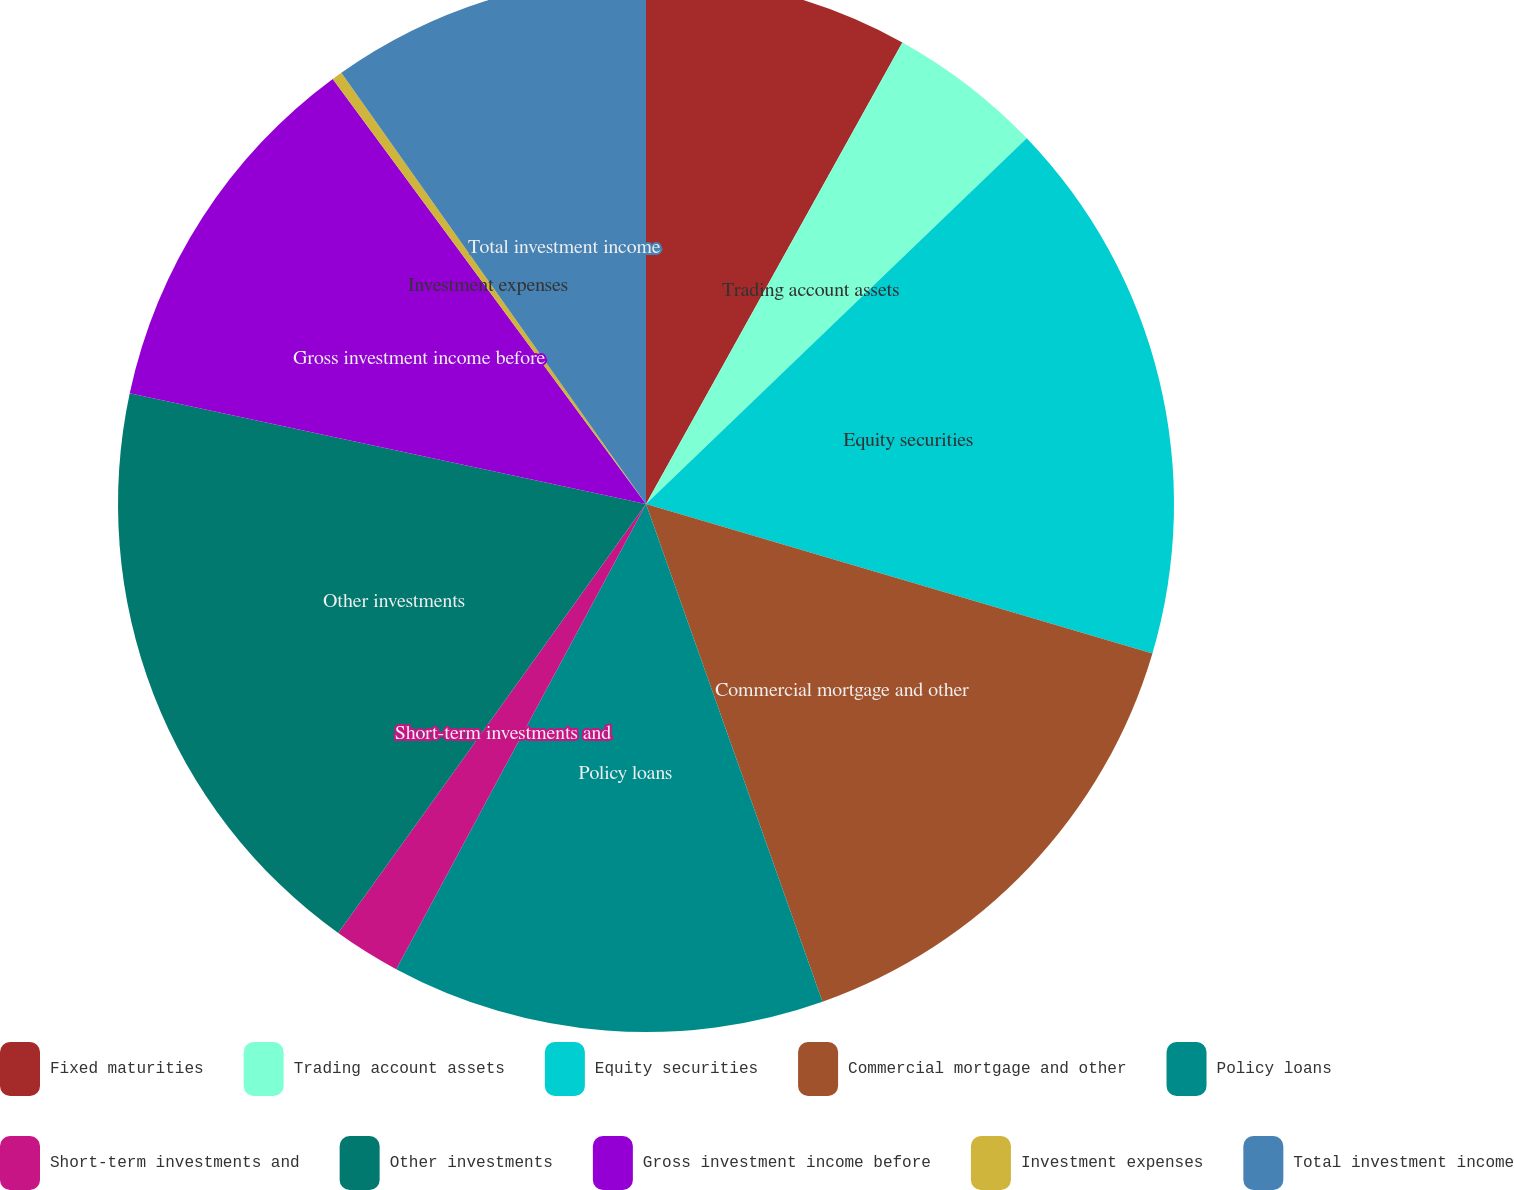<chart> <loc_0><loc_0><loc_500><loc_500><pie_chart><fcel>Fixed maturities<fcel>Trading account assets<fcel>Equity securities<fcel>Commercial mortgage and other<fcel>Policy loans<fcel>Short-term investments and<fcel>Other investments<fcel>Gross investment income before<fcel>Investment expenses<fcel>Total investment income<nl><fcel>8.07%<fcel>4.75%<fcel>16.75%<fcel>15.01%<fcel>13.27%<fcel>2.06%<fcel>18.46%<fcel>11.53%<fcel>0.32%<fcel>9.79%<nl></chart> 